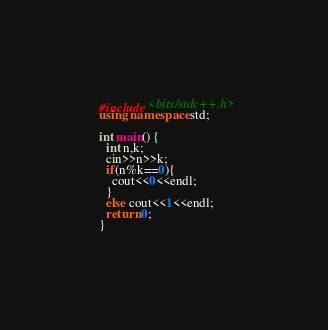<code> <loc_0><loc_0><loc_500><loc_500><_C++_>#include <bits/stdc++.h>
using namespace std;

int main() {
  int n,k;
  cin>>n>>k;
  if(n%k==0){
    cout<<0<<endl;
  }
  else cout<<1<<endl;
  return 0;
}</code> 